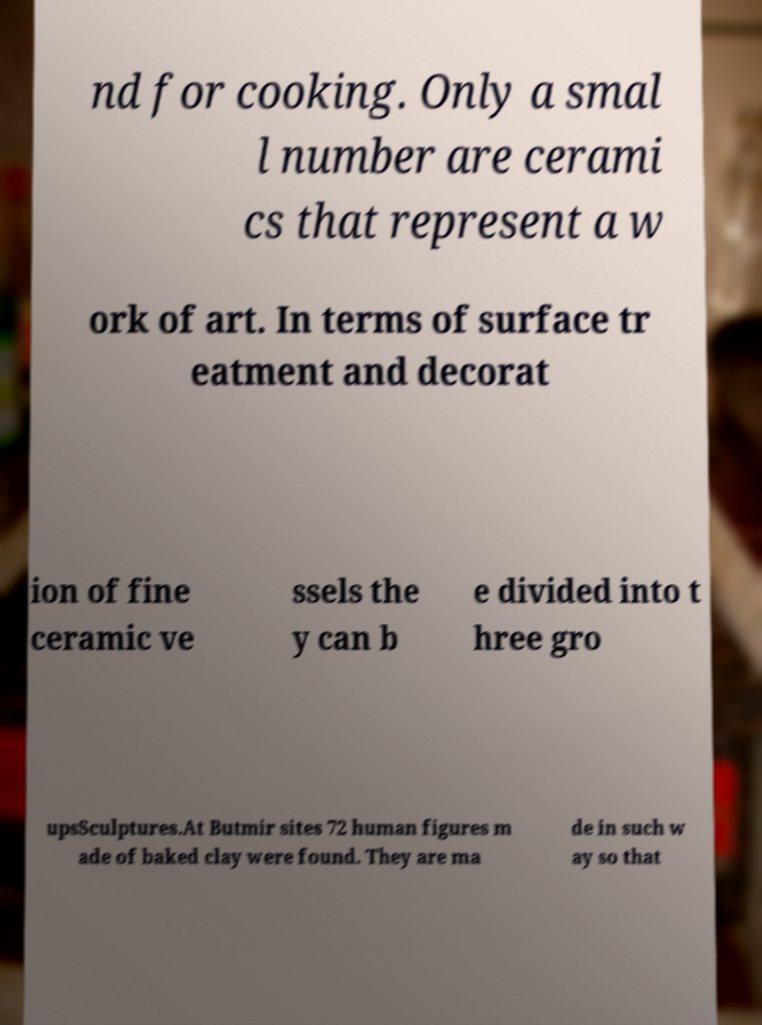Please identify and transcribe the text found in this image. nd for cooking. Only a smal l number are cerami cs that represent a w ork of art. In terms of surface tr eatment and decorat ion of fine ceramic ve ssels the y can b e divided into t hree gro upsSculptures.At Butmir sites 72 human figures m ade of baked clay were found. They are ma de in such w ay so that 